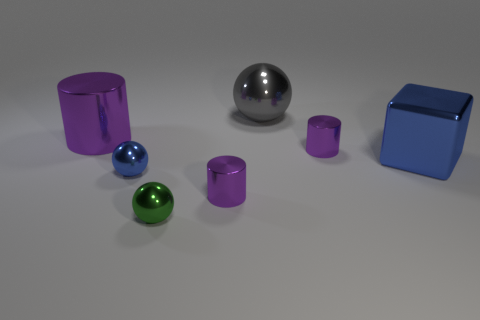Is the color of the tiny cylinder that is left of the large sphere the same as the shiny sphere that is behind the large metallic cylinder?
Provide a succinct answer. No. Are there more metallic spheres on the right side of the big metallic block than shiny spheres?
Keep it short and to the point. No. There is a large purple thing that is made of the same material as the large cube; what is its shape?
Ensure brevity in your answer.  Cylinder. Do the purple cylinder in front of the blue cube and the gray sphere have the same size?
Provide a succinct answer. No. The small purple metal thing left of the tiny metallic cylinder right of the large metal ball is what shape?
Make the answer very short. Cylinder. How big is the blue metal thing on the right side of the small purple cylinder right of the gray object?
Provide a succinct answer. Large. The tiny ball behind the green sphere is what color?
Provide a short and direct response. Blue. What is the size of the gray ball that is the same material as the large cylinder?
Your answer should be compact. Large. How many large metal objects have the same shape as the small green shiny object?
Offer a terse response. 1. There is a purple cylinder that is the same size as the gray shiny object; what material is it?
Provide a succinct answer. Metal. 